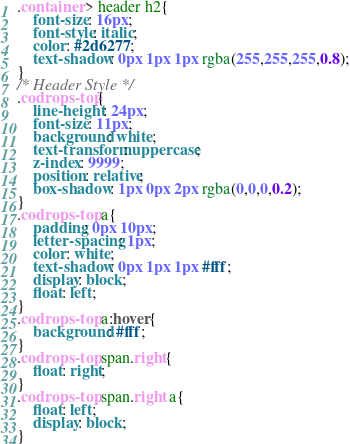Convert code to text. <code><loc_0><loc_0><loc_500><loc_500><_CSS_>.container > header h2{
	font-size: 16px;
	font-style: italic;
	color: #2d6277;
	text-shadow: 0px 1px 1px rgba(255,255,255,0.8);
}
/* Header Style */
.codrops-top{
	line-height: 24px;
	font-size: 11px;
	background: white;
	text-transform: uppercase;
	z-index: 9999;
	position: relative;
	box-shadow: 1px 0px 2px rgba(0,0,0,0.2);
}
.codrops-top a{
	padding: 0px 10px;
	letter-spacing: 1px;
	color: white;
	text-shadow: 0px 1px 1px #fff;
	display: block;
	float: left;
}
.codrops-top a:hover{
	background: #fff;
}
.codrops-top span.right{
	float: right;
}
.codrops-top span.right a{
	float: left;
	display: block;
}

</code> 